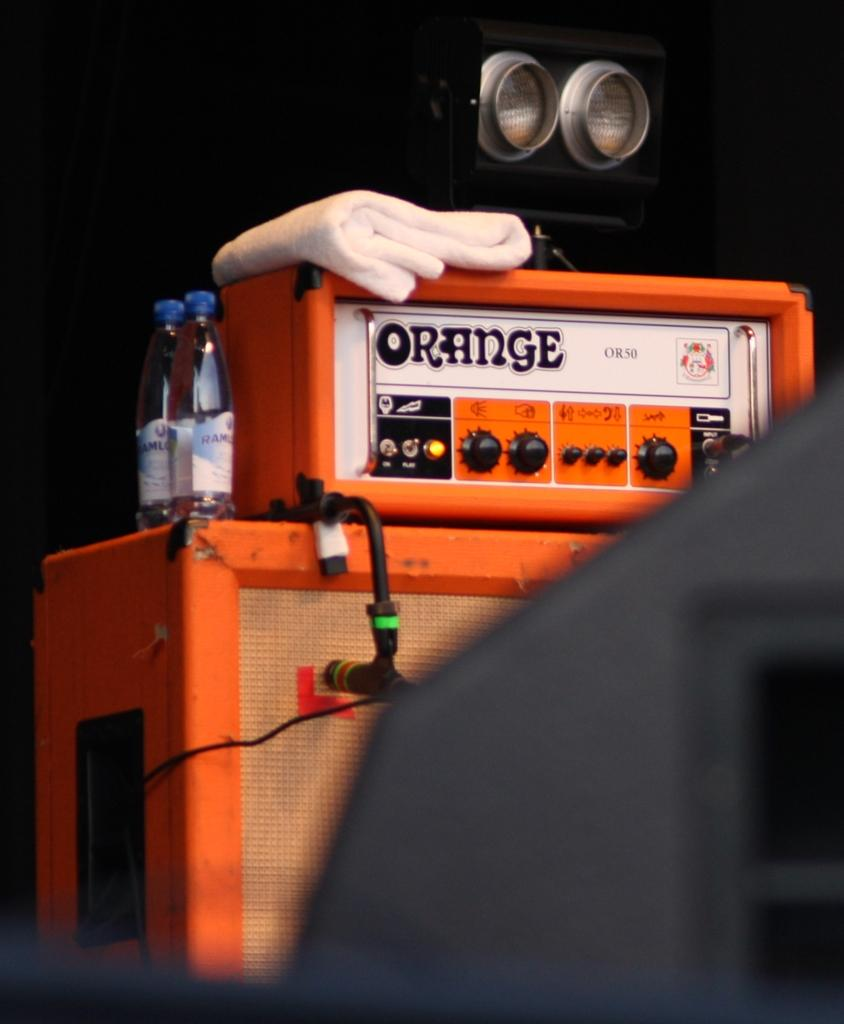<image>
Relay a brief, clear account of the picture shown. A guitar amplifier from the brand Orange has a towel sitting on top of it. 